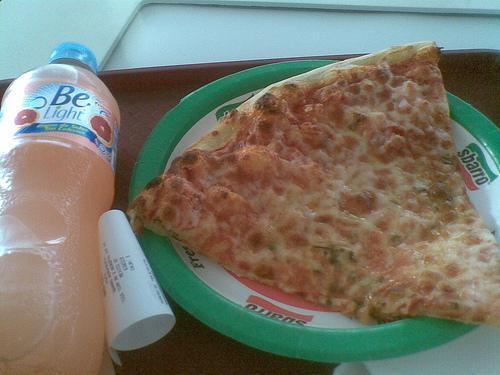How many drink bottles are in the picture?
Give a very brief answer. 1. 